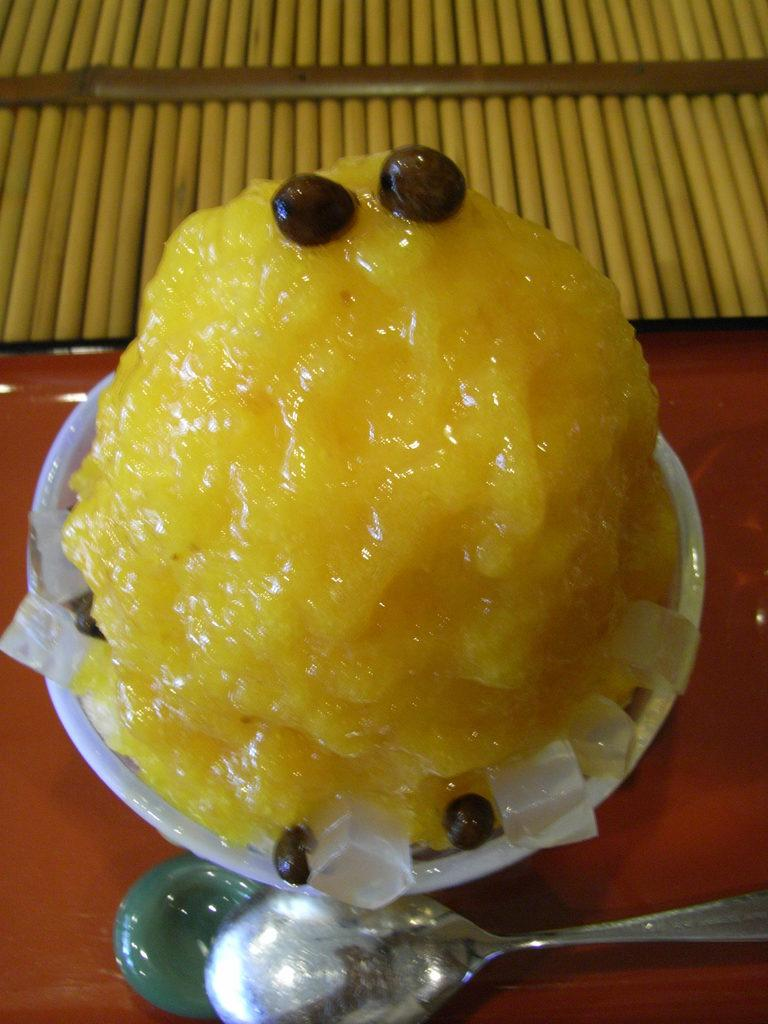What type of dessert is in the cup in the image? There is a yellow color dessert in a cup. What utensil is placed beside the cup? There is a spoon beside the cup. What type of boundary can be seen in the image? There is no boundary present in the image; it features a cup with a yellow dessert and a spoon. Can you tell me how many airplanes are visible in the image? There are no airplanes present in the image. What is the level of love depicted in the image? The image does not depict any emotions or relationships, so it is not possible to determine the level of love. 